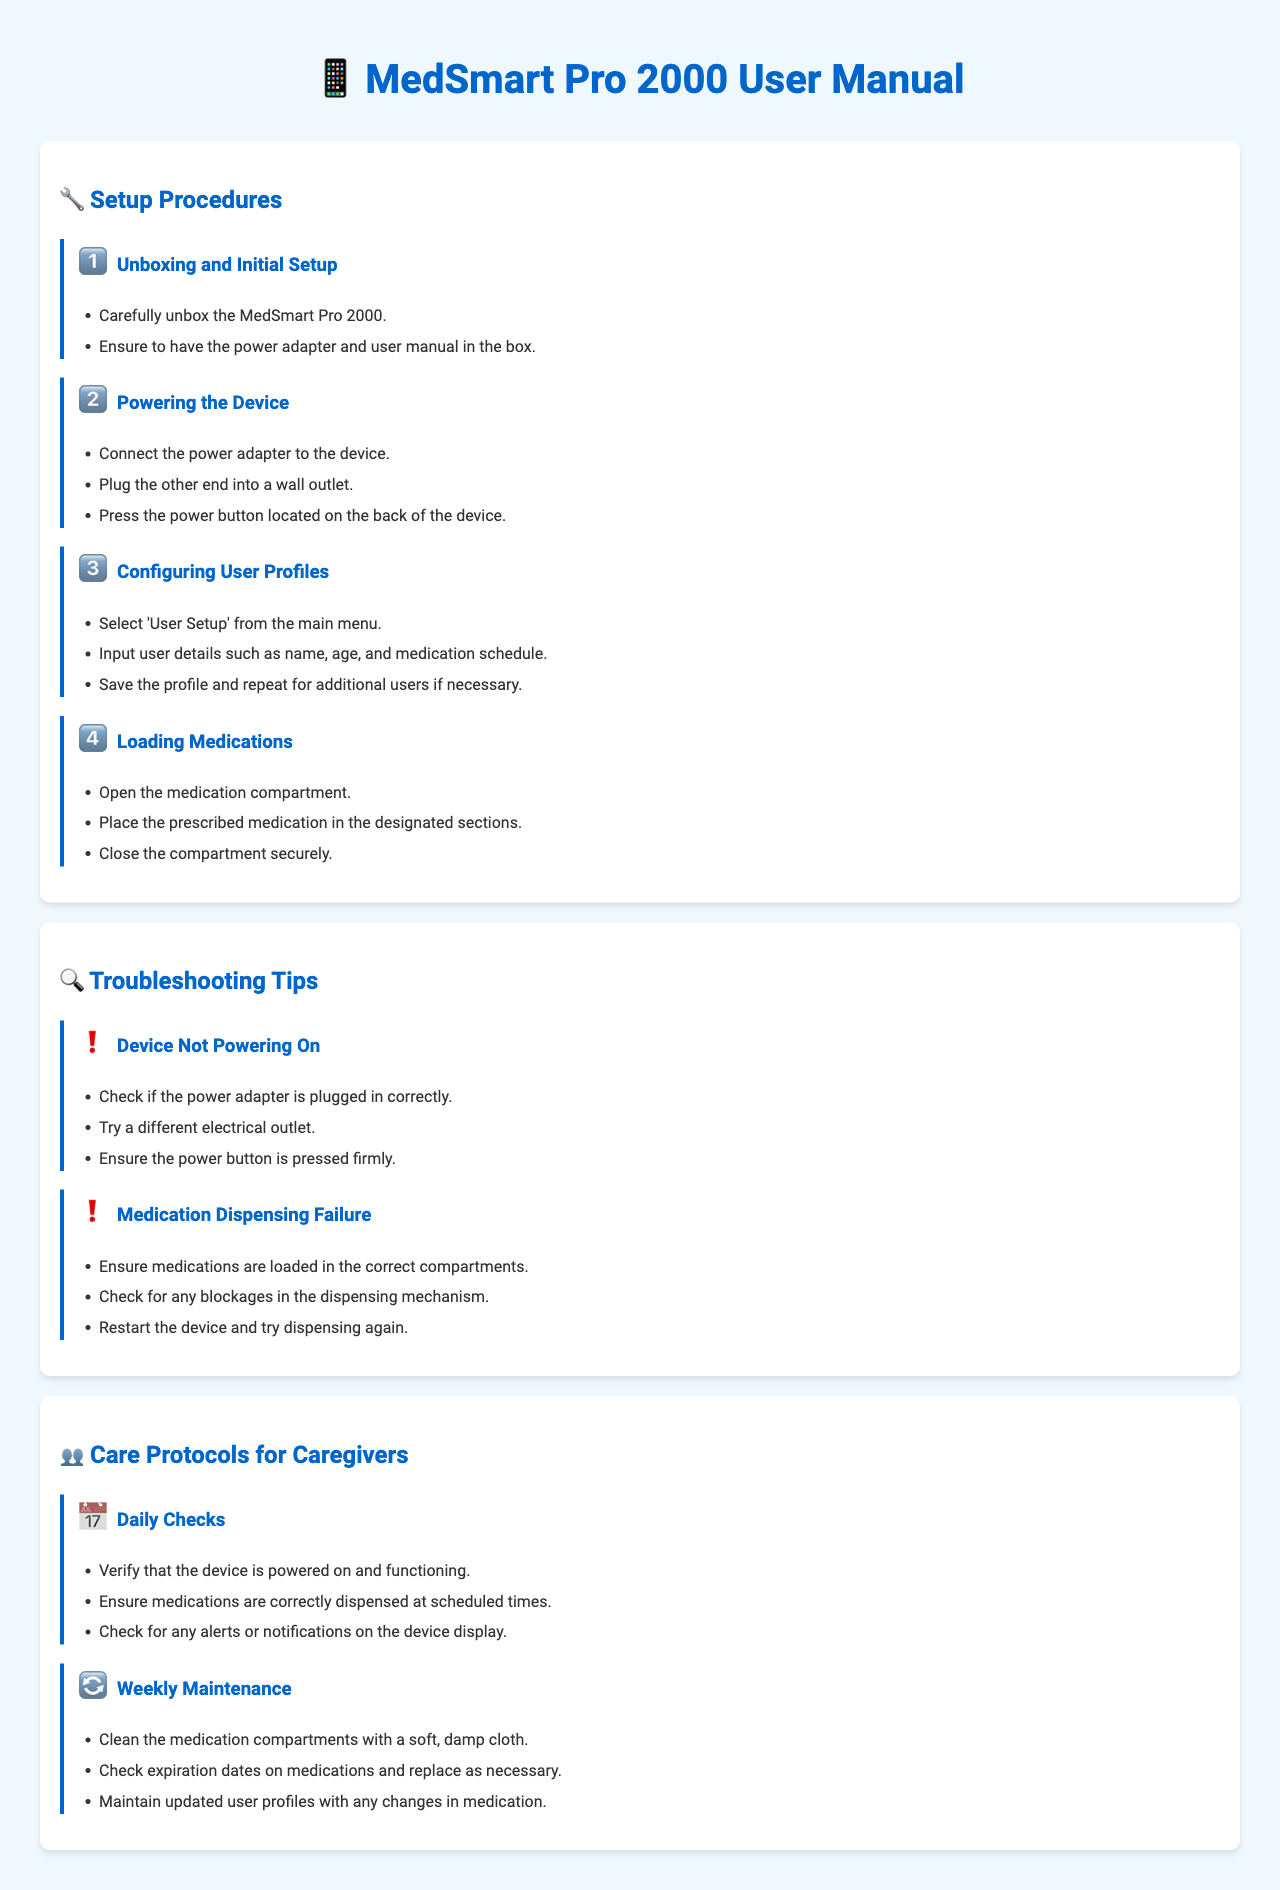What is the name of the device? The title of the manual states that the device is named "MedSmart Pro 2000."
Answer: MedSmart Pro 2000 How many steps are in the setup procedures? The setup procedures section outlines four distinct steps for configuration.
Answer: Four What should you do if the device is not powering on? The document provides specific troubleshooting tips, including checking the power adapter and trying a different outlet.
Answer: Check the power adapter What is one of the daily checks for caregivers? The care protocols section mentions verifying the device is powered on and functioning as a daily check.
Answer: Device is powered on What should you do during weekly maintenance? The weekly maintenance section recommends cleaning the medication compartments with a soft, damp cloth.
Answer: Clean medication compartments What is the first step in the setup procedures? The first step listed in the setup procedures highlights unboxing and initial setup.
Answer: Unboxing and Initial Setup What action should be taken if there is a medication dispensing failure? The troubleshooting tips section advises checking for blockages in the dispensing mechanism during such an event.
Answer: Check for blockages How often should caregivers check expiration dates on medications? According to the weekly maintenance protocol, caregivers should perform this check every week.
Answer: Weekly Which menu option do you select to configure user profiles? The document states that you should select 'User Setup' from the main menu for this configuration.
Answer: User Setup 